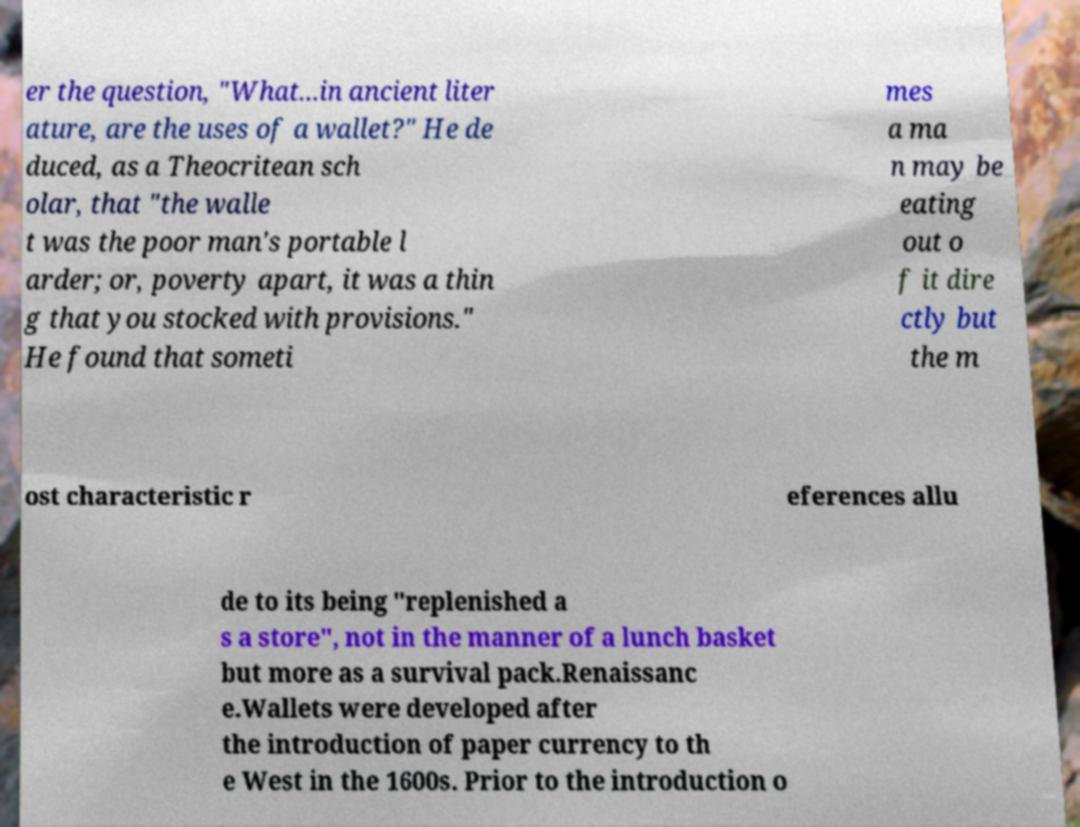Can you accurately transcribe the text from the provided image for me? er the question, "What...in ancient liter ature, are the uses of a wallet?" He de duced, as a Theocritean sch olar, that "the walle t was the poor man's portable l arder; or, poverty apart, it was a thin g that you stocked with provisions." He found that someti mes a ma n may be eating out o f it dire ctly but the m ost characteristic r eferences allu de to its being "replenished a s a store", not in the manner of a lunch basket but more as a survival pack.Renaissanc e.Wallets were developed after the introduction of paper currency to th e West in the 1600s. Prior to the introduction o 